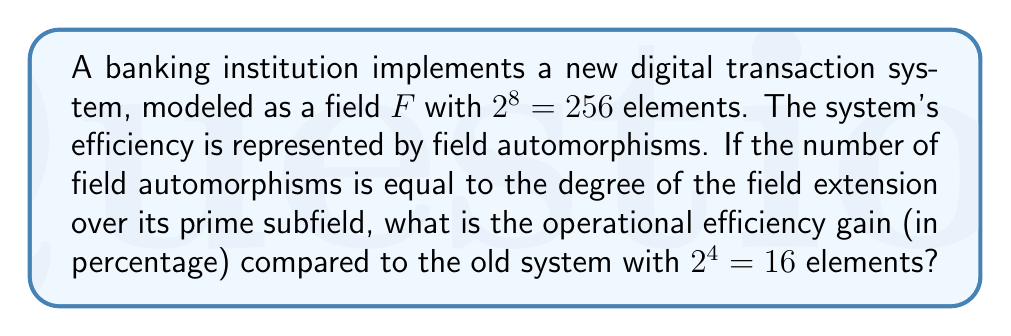Could you help me with this problem? Let's approach this step-by-step:

1) For a finite field $F$ with $p^n$ elements (where $p$ is prime), the number of automorphisms is equal to $n$.

2) In our case, the new system has $2^8 = 256$ elements. So, $p = 2$ and $n = 8$.

3) The number of automorphisms for the new system is therefore 8.

4) For the old system with $2^4 = 16$ elements, $p = 2$ and $n = 4$.

5) The number of automorphisms for the old system is 4.

6) To calculate the efficiency gain, we use:

   $$\text{Efficiency Gain} = \frac{\text{New Efficiency} - \text{Old Efficiency}}{\text{Old Efficiency}} \times 100\%$$

7) Substituting our values:

   $$\text{Efficiency Gain} = \frac{8 - 4}{4} \times 100\% = \frac{4}{4} \times 100\% = 100\%$$

Therefore, the operational efficiency gain is 100%.
Answer: 100% 